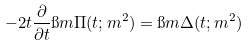<formula> <loc_0><loc_0><loc_500><loc_500>- 2 t \frac { \partial } { \partial t } \i m \Pi ( t ; m ^ { 2 } ) = \i m \Delta ( t ; m ^ { 2 } )</formula> 